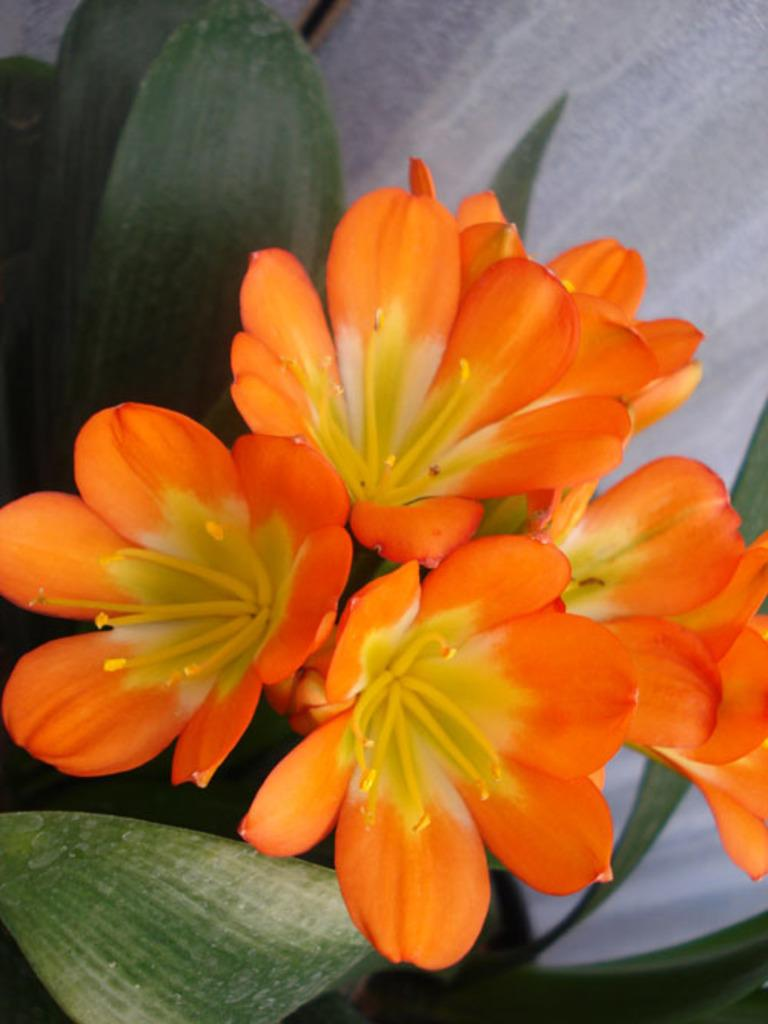What is present in the image? There is a plant in the image. What can be observed about the plant's flowers? The plant has orange flowers. Can you describe the setting or background of the image? The image appears to be of a wall. What channel is the committee watching in the image? There is no reference to a channel or committee in the image; it features a plant with orange flowers against a wall. 